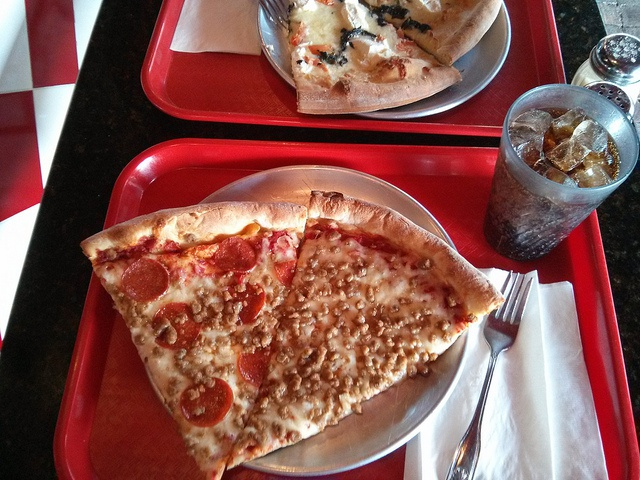Describe the objects in this image and their specific colors. I can see dining table in black, maroon, brown, and white tones, pizza in white, brown, and maroon tones, cup in white, gray, maroon, black, and darkgray tones, pizza in white, tan, salmon, and ivory tones, and fork in white, gray, darkgray, and maroon tones in this image. 